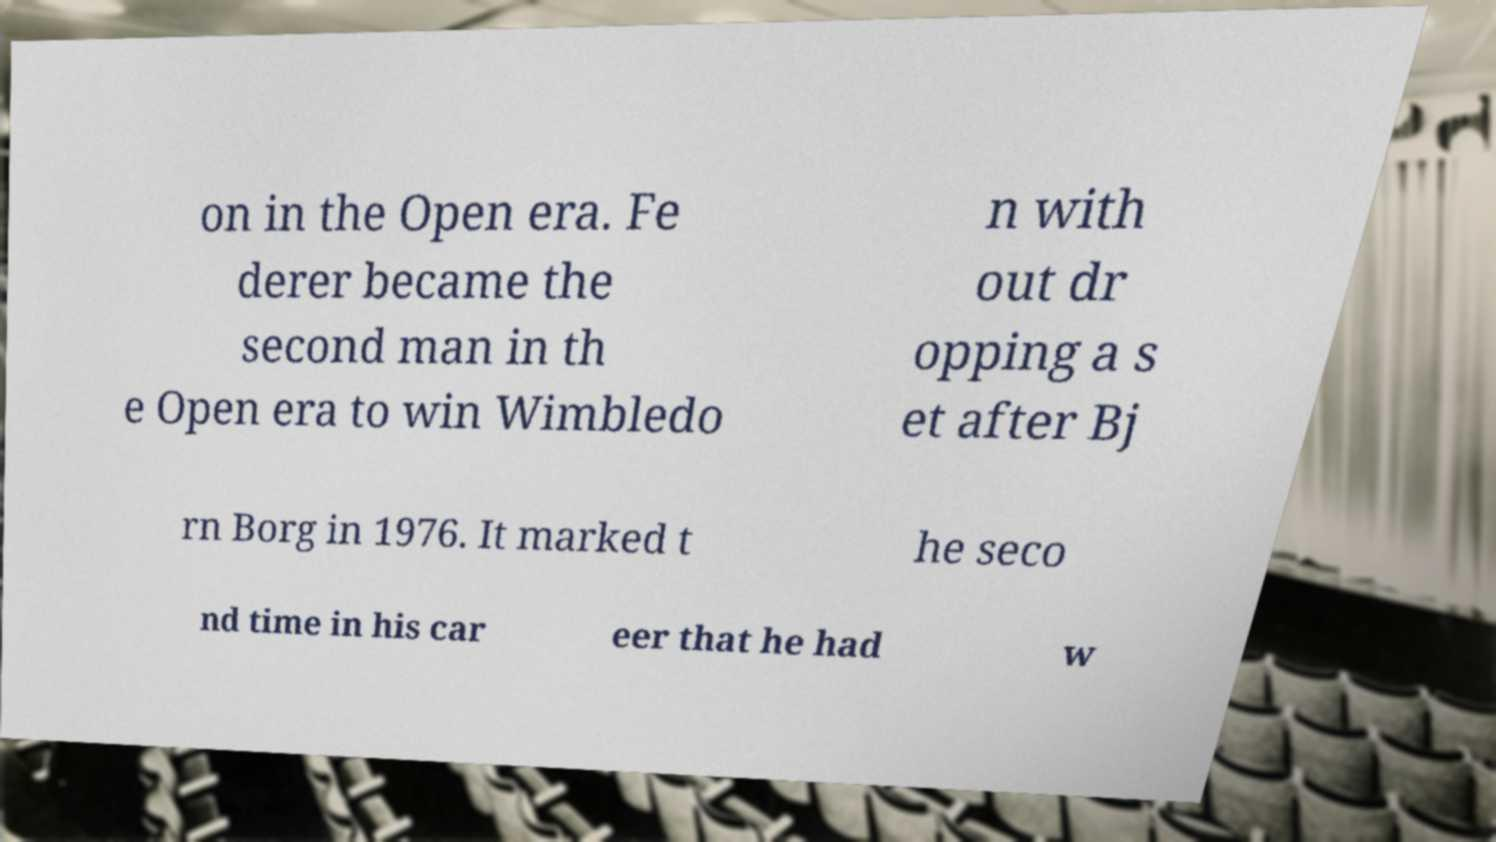Can you read and provide the text displayed in the image?This photo seems to have some interesting text. Can you extract and type it out for me? on in the Open era. Fe derer became the second man in th e Open era to win Wimbledo n with out dr opping a s et after Bj rn Borg in 1976. It marked t he seco nd time in his car eer that he had w 